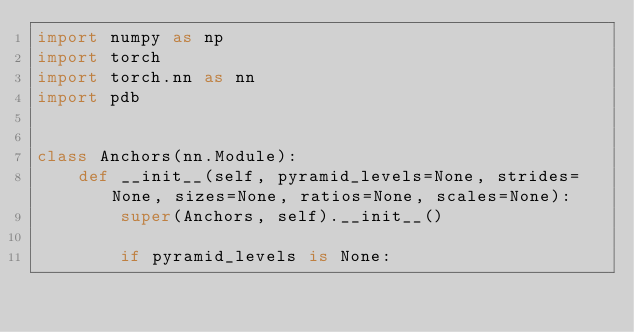<code> <loc_0><loc_0><loc_500><loc_500><_Python_>import numpy as np
import torch
import torch.nn as nn
import pdb


class Anchors(nn.Module):
    def __init__(self, pyramid_levels=None, strides=None, sizes=None, ratios=None, scales=None):
        super(Anchors, self).__init__()

        if pyramid_levels is None:</code> 